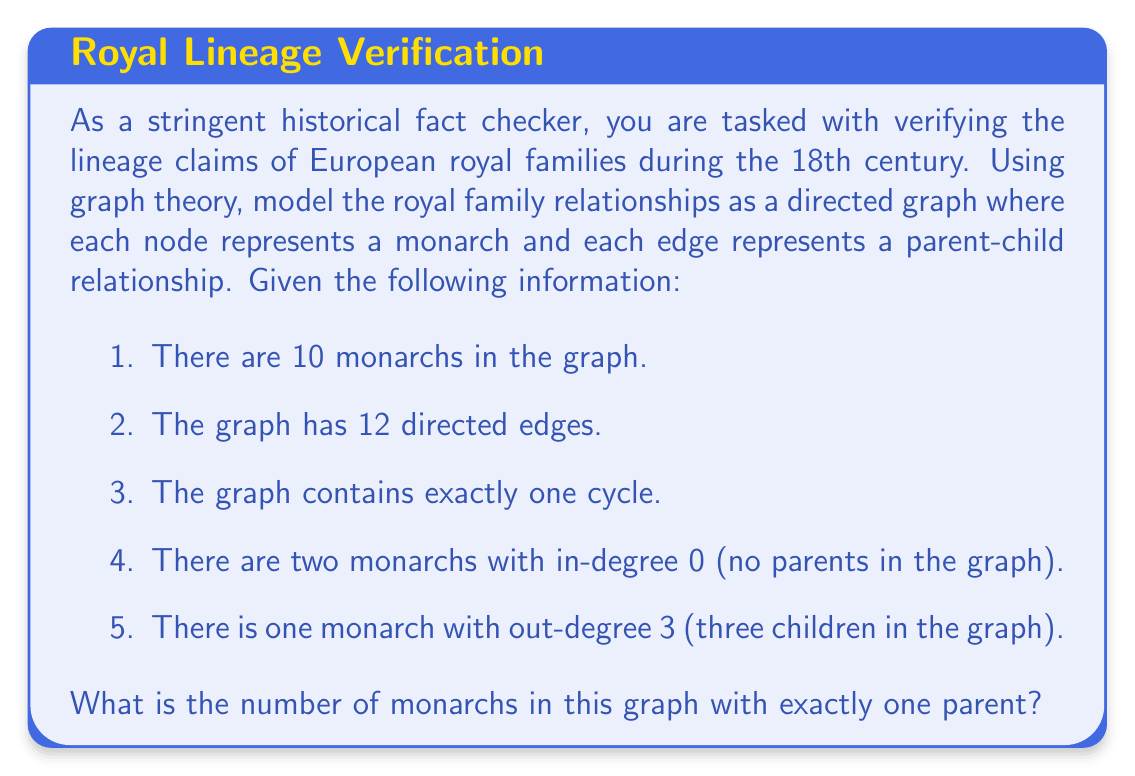Help me with this question. Let's approach this step-by-step using graph theory concepts:

1) Let $n$ be the number of nodes (monarchs) and $e$ be the number of edges (parent-child relationships).
   Given: $n = 10$, $e = 12$

2) In a directed graph, the sum of all in-degrees equals the sum of all out-degrees, which equals the total number of edges. So:

   $$\sum_{v \in V} \text{in-degree}(v) = \sum_{v \in V} \text{out-degree}(v) = e = 12$$

3) We're told there are two monarchs with in-degree 0 and one monarch with out-degree 3. Let $x$ be the number of monarchs with exactly one parent. Then:

   $$2 \cdot 0 + x \cdot 1 + (8-x) \cdot 2 = 12$$

   This is because the remaining $(8-x)$ monarchs must have 2 parents each to form the cycle.

4) Simplifying the equation:

   $$x + 16 - 2x = 12$$
   $$-x = -4$$
   $$x = 4$$

5) We can verify this result:
   - 2 monarchs with 0 parents
   - 4 monarchs with 1 parent
   - 4 monarchs with 2 parents

   This accounts for all 10 monarchs and satisfies all given conditions.
Answer: 4 monarchs have exactly one parent in the graph. 